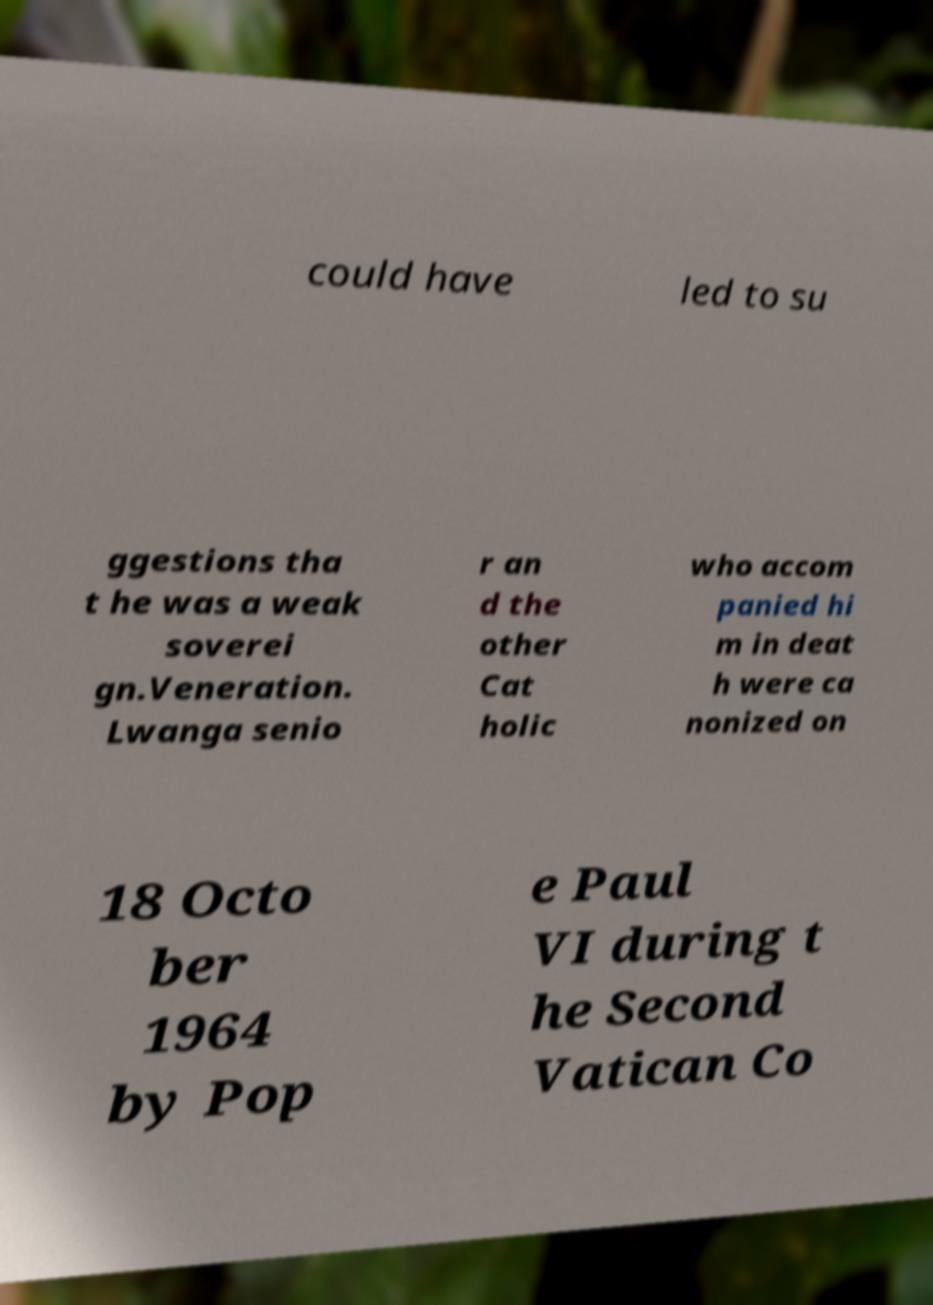Can you read and provide the text displayed in the image?This photo seems to have some interesting text. Can you extract and type it out for me? could have led to su ggestions tha t he was a weak soverei gn.Veneration. Lwanga senio r an d the other Cat holic who accom panied hi m in deat h were ca nonized on 18 Octo ber 1964 by Pop e Paul VI during t he Second Vatican Co 